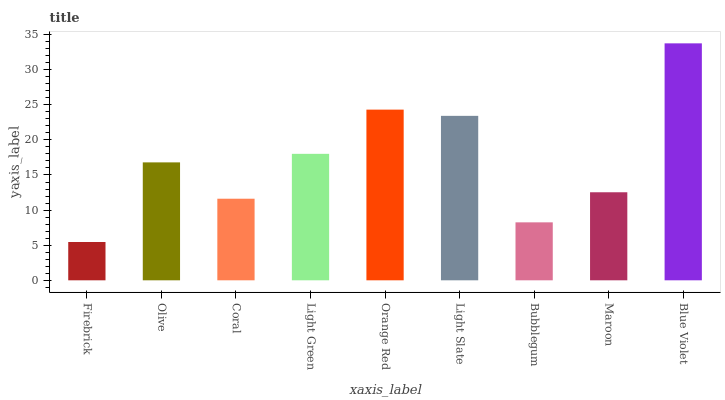Is Olive the minimum?
Answer yes or no. No. Is Olive the maximum?
Answer yes or no. No. Is Olive greater than Firebrick?
Answer yes or no. Yes. Is Firebrick less than Olive?
Answer yes or no. Yes. Is Firebrick greater than Olive?
Answer yes or no. No. Is Olive less than Firebrick?
Answer yes or no. No. Is Olive the high median?
Answer yes or no. Yes. Is Olive the low median?
Answer yes or no. Yes. Is Orange Red the high median?
Answer yes or no. No. Is Firebrick the low median?
Answer yes or no. No. 